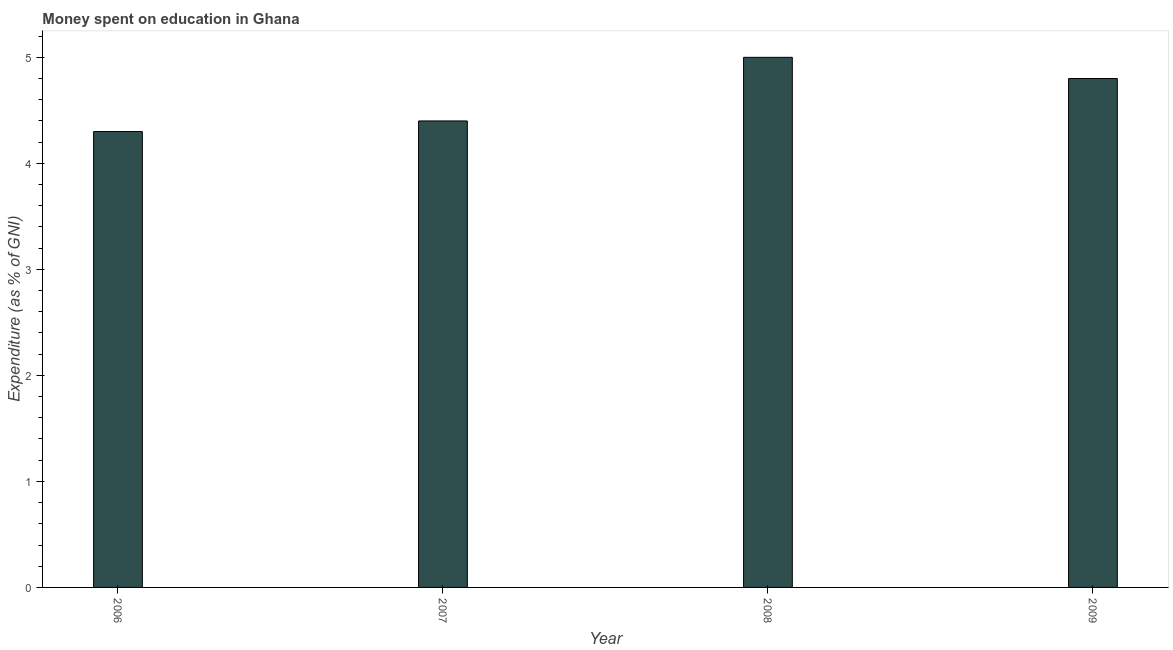Does the graph contain any zero values?
Make the answer very short. No. What is the title of the graph?
Provide a short and direct response. Money spent on education in Ghana. What is the label or title of the Y-axis?
Provide a succinct answer. Expenditure (as % of GNI). What is the expenditure on education in 2007?
Offer a very short reply. 4.4. Across all years, what is the maximum expenditure on education?
Your response must be concise. 5. Across all years, what is the minimum expenditure on education?
Make the answer very short. 4.3. In which year was the expenditure on education maximum?
Ensure brevity in your answer.  2008. In which year was the expenditure on education minimum?
Ensure brevity in your answer.  2006. What is the sum of the expenditure on education?
Provide a short and direct response. 18.5. What is the difference between the expenditure on education in 2006 and 2008?
Offer a very short reply. -0.7. What is the average expenditure on education per year?
Give a very brief answer. 4.62. In how many years, is the expenditure on education greater than 0.6 %?
Your response must be concise. 4. What is the ratio of the expenditure on education in 2007 to that in 2009?
Offer a very short reply. 0.92. Is the expenditure on education in 2007 less than that in 2009?
Offer a very short reply. Yes. Is the sum of the expenditure on education in 2007 and 2008 greater than the maximum expenditure on education across all years?
Give a very brief answer. Yes. What is the difference between the highest and the lowest expenditure on education?
Your response must be concise. 0.7. How many bars are there?
Ensure brevity in your answer.  4. Are all the bars in the graph horizontal?
Give a very brief answer. No. What is the difference between two consecutive major ticks on the Y-axis?
Your answer should be compact. 1. What is the difference between the Expenditure (as % of GNI) in 2006 and 2008?
Provide a succinct answer. -0.7. What is the difference between the Expenditure (as % of GNI) in 2006 and 2009?
Make the answer very short. -0.5. What is the difference between the Expenditure (as % of GNI) in 2008 and 2009?
Ensure brevity in your answer.  0.2. What is the ratio of the Expenditure (as % of GNI) in 2006 to that in 2007?
Make the answer very short. 0.98. What is the ratio of the Expenditure (as % of GNI) in 2006 to that in 2008?
Offer a very short reply. 0.86. What is the ratio of the Expenditure (as % of GNI) in 2006 to that in 2009?
Your answer should be compact. 0.9. What is the ratio of the Expenditure (as % of GNI) in 2007 to that in 2009?
Provide a succinct answer. 0.92. What is the ratio of the Expenditure (as % of GNI) in 2008 to that in 2009?
Offer a very short reply. 1.04. 